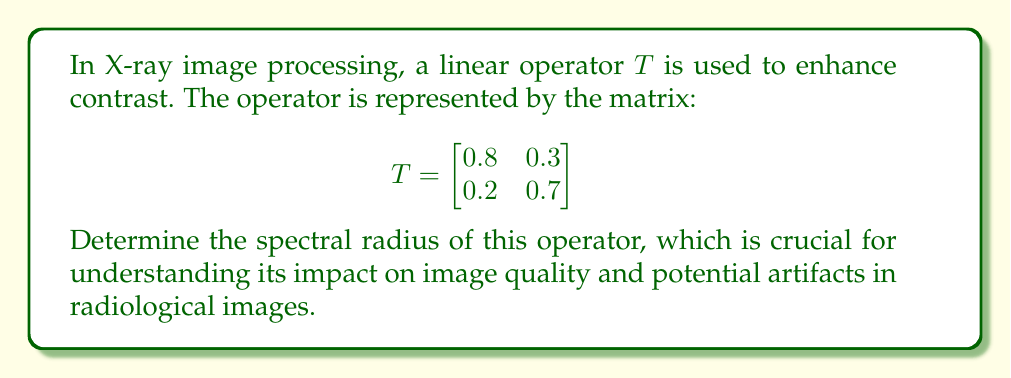Provide a solution to this math problem. To determine the spectral radius of the linear operator $T$, we follow these steps:

1) The spectral radius is the maximum of the absolute values of the eigenvalues of $T$.

2) To find the eigenvalues, we solve the characteristic equation:
   $$\det(T - \lambda I) = 0$$

3) Expanding this:
   $$\begin{vmatrix}
   0.8 - \lambda & 0.3 \\
   0.2 & 0.7 - \lambda
   \end{vmatrix} = 0$$

4) This gives us:
   $$(0.8 - \lambda)(0.7 - \lambda) - 0.06 = 0$$

5) Simplifying:
   $$\lambda^2 - 1.5\lambda + 0.5 = 0$$

6) Using the quadratic formula, we get:
   $$\lambda = \frac{1.5 \pm \sqrt{1.5^2 - 4(0.5)}}{2} = \frac{1.5 \pm \sqrt{1.25}}{2}$$

7) This gives us two eigenvalues:
   $$\lambda_1 = \frac{1.5 + \sqrt{1.25}}{2} \approx 1.0590$$
   $$\lambda_2 = \frac{1.5 - \sqrt{1.25}}{2} \approx 0.4410$$

8) The spectral radius is the maximum of the absolute values of these eigenvalues:
   $$\rho(T) = \max(|\lambda_1|, |\lambda_2|) = |\lambda_1| \approx 1.0590$$

This spectral radius being slightly greater than 1 indicates that the operator may slightly amplify certain features in the X-ray image, which could potentially enhance contrast but also risk amplifying noise.
Answer: $\rho(T) \approx 1.0590$ 